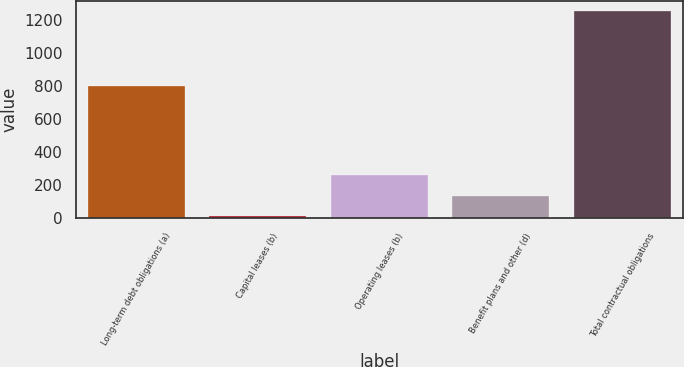Convert chart. <chart><loc_0><loc_0><loc_500><loc_500><bar_chart><fcel>Long-term debt obligations (a)<fcel>Capital leases (b)<fcel>Operating leases (b)<fcel>Benefit plans and other (d)<fcel>Total contractual obligations<nl><fcel>801<fcel>13<fcel>261.2<fcel>137.1<fcel>1254<nl></chart> 